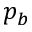<formula> <loc_0><loc_0><loc_500><loc_500>p _ { b }</formula> 